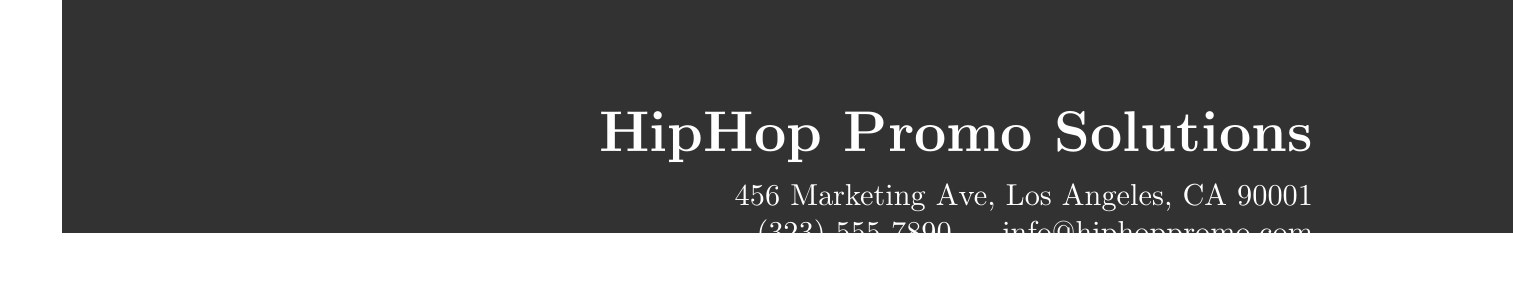What is the invoice number? The invoice number is clearly stated in the document under invoice details, which is "INV-2023-0605."
Answer: INV-2023-0605 What is the due date of the invoice? The due date is specified in the document, which is June 19, 2023.
Answer: June 19, 2023 How much is the total amount due? The total amount due is calculated and listed at the bottom of the invoice as $1642.45.
Answer: $1642.45 Who is the account manager to contact for questions? The document indicates that the account manager is Malik Johnson, responsible for any inquiries.
Answer: Malik Johnson What service includes daily posts on social media? The service related to daily posts is "Social Media Management (30 days)," as detailed in the services list.
Answer: Social Media Management (30 days) What is the percentage for tax calculation? The tax rate applied to the invoice is mentioned as 9.5%.
Answer: 9.5% How many curators are pitched for Spotify Playlist? The document states that there is a pitch to 50 curators of hip-hop playlists.
Answer: 50 What is the unit price of the Custom Beatport Banner Design service? The unit price listed for the Custom Beatport Banner Design service is $149.99.
Answer: $149.99 What payment methods are accepted? The document lists multiple payment methods including PayPal, Venmo, and Bank Transfer.
Answer: PayPal, Venmo, Bank Transfer 